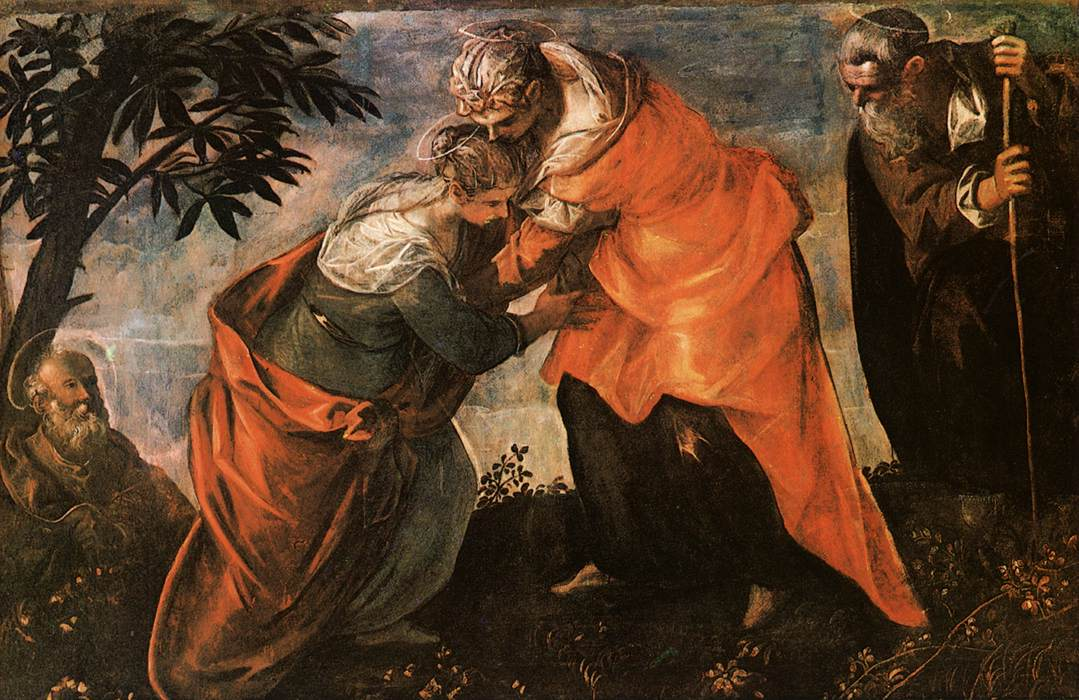How does the artist's use of color impact the depiction of this biblical story? The artist's use of vibrant colors plays a crucial role in the painting. The rich reds and deep blues not only draw attention to Mary and Elizabeth but also signify their importance and virtue. Color in Renaissance paintings is often loaded with symbolism; for example, blue can represent heavenly grace, while red might symbolize love or martyrdom. Here, the bright colors amidst a darker, softer background help to focus the viewer's eye on the emotional center of the painting— the intimate and joyous meeting of the two women. What can be inferred about the figures in the background? The background figures in Renaissance paintings are typically not just fillers but have roles that further the narrative or theme. The male figure with the staff could be Zechariah, Elizabeth's husband, who in the Bible is rendered temporarily mute for his disbelief in the news of a child born to him in old age. His presence adds to the layers of the story, providing a contrast to the faith and acceptance shown by the women. His contemplative pose might suggest reflection on the miraculous nature of the events unfolding before him. 